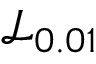<formula> <loc_0><loc_0><loc_500><loc_500>\mathcal { L } _ { 0 . 0 1 }</formula> 